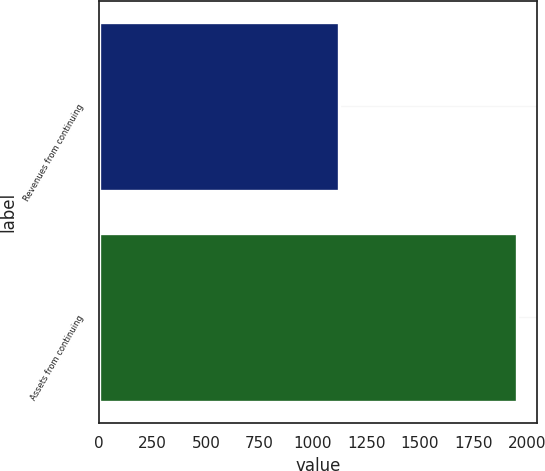Convert chart to OTSL. <chart><loc_0><loc_0><loc_500><loc_500><bar_chart><fcel>Revenues from continuing<fcel>Assets from continuing<nl><fcel>1119.9<fcel>1951.3<nl></chart> 